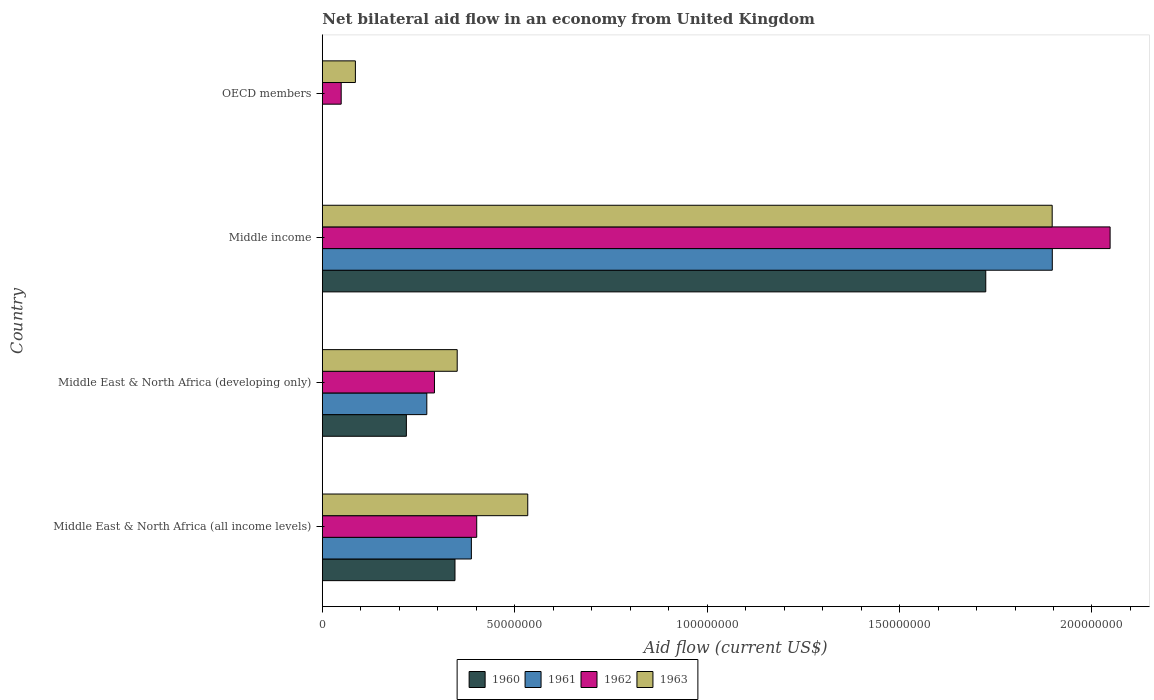How many different coloured bars are there?
Make the answer very short. 4. Are the number of bars per tick equal to the number of legend labels?
Your response must be concise. No. Are the number of bars on each tick of the Y-axis equal?
Your response must be concise. No. How many bars are there on the 4th tick from the top?
Ensure brevity in your answer.  4. How many bars are there on the 1st tick from the bottom?
Keep it short and to the point. 4. Across all countries, what is the maximum net bilateral aid flow in 1961?
Keep it short and to the point. 1.90e+08. What is the total net bilateral aid flow in 1961 in the graph?
Give a very brief answer. 2.56e+08. What is the difference between the net bilateral aid flow in 1963 in Middle East & North Africa (developing only) and that in Middle income?
Offer a terse response. -1.55e+08. What is the difference between the net bilateral aid flow in 1961 in Middle East & North Africa (all income levels) and the net bilateral aid flow in 1960 in Middle income?
Provide a succinct answer. -1.34e+08. What is the average net bilateral aid flow in 1961 per country?
Your answer should be compact. 6.39e+07. What is the difference between the net bilateral aid flow in 1961 and net bilateral aid flow in 1962 in Middle East & North Africa (all income levels)?
Provide a short and direct response. -1.39e+06. What is the ratio of the net bilateral aid flow in 1960 in Middle East & North Africa (developing only) to that in Middle income?
Your answer should be compact. 0.13. Is the difference between the net bilateral aid flow in 1961 in Middle East & North Africa (all income levels) and Middle income greater than the difference between the net bilateral aid flow in 1962 in Middle East & North Africa (all income levels) and Middle income?
Provide a succinct answer. Yes. What is the difference between the highest and the second highest net bilateral aid flow in 1960?
Your answer should be very brief. 1.38e+08. What is the difference between the highest and the lowest net bilateral aid flow in 1962?
Keep it short and to the point. 2.00e+08. Is the sum of the net bilateral aid flow in 1962 in Middle East & North Africa (all income levels) and Middle income greater than the maximum net bilateral aid flow in 1963 across all countries?
Keep it short and to the point. Yes. Is it the case that in every country, the sum of the net bilateral aid flow in 1963 and net bilateral aid flow in 1960 is greater than the net bilateral aid flow in 1961?
Offer a very short reply. Yes. Are all the bars in the graph horizontal?
Keep it short and to the point. Yes. How many countries are there in the graph?
Keep it short and to the point. 4. Does the graph contain any zero values?
Offer a terse response. Yes. How many legend labels are there?
Make the answer very short. 4. What is the title of the graph?
Provide a succinct answer. Net bilateral aid flow in an economy from United Kingdom. What is the label or title of the X-axis?
Make the answer very short. Aid flow (current US$). What is the Aid flow (current US$) of 1960 in Middle East & North Africa (all income levels)?
Your response must be concise. 3.45e+07. What is the Aid flow (current US$) of 1961 in Middle East & North Africa (all income levels)?
Your answer should be very brief. 3.87e+07. What is the Aid flow (current US$) of 1962 in Middle East & North Africa (all income levels)?
Offer a terse response. 4.01e+07. What is the Aid flow (current US$) in 1963 in Middle East & North Africa (all income levels)?
Give a very brief answer. 5.34e+07. What is the Aid flow (current US$) of 1960 in Middle East & North Africa (developing only)?
Your response must be concise. 2.18e+07. What is the Aid flow (current US$) of 1961 in Middle East & North Africa (developing only)?
Offer a very short reply. 2.72e+07. What is the Aid flow (current US$) in 1962 in Middle East & North Africa (developing only)?
Your answer should be compact. 2.91e+07. What is the Aid flow (current US$) in 1963 in Middle East & North Africa (developing only)?
Keep it short and to the point. 3.50e+07. What is the Aid flow (current US$) in 1960 in Middle income?
Make the answer very short. 1.72e+08. What is the Aid flow (current US$) of 1961 in Middle income?
Offer a very short reply. 1.90e+08. What is the Aid flow (current US$) in 1962 in Middle income?
Offer a very short reply. 2.05e+08. What is the Aid flow (current US$) of 1963 in Middle income?
Make the answer very short. 1.90e+08. What is the Aid flow (current US$) in 1962 in OECD members?
Your response must be concise. 4.90e+06. What is the Aid flow (current US$) in 1963 in OECD members?
Offer a terse response. 8.59e+06. Across all countries, what is the maximum Aid flow (current US$) of 1960?
Provide a succinct answer. 1.72e+08. Across all countries, what is the maximum Aid flow (current US$) of 1961?
Provide a short and direct response. 1.90e+08. Across all countries, what is the maximum Aid flow (current US$) in 1962?
Provide a short and direct response. 2.05e+08. Across all countries, what is the maximum Aid flow (current US$) of 1963?
Your answer should be compact. 1.90e+08. Across all countries, what is the minimum Aid flow (current US$) of 1960?
Give a very brief answer. 0. Across all countries, what is the minimum Aid flow (current US$) of 1962?
Keep it short and to the point. 4.90e+06. Across all countries, what is the minimum Aid flow (current US$) of 1963?
Give a very brief answer. 8.59e+06. What is the total Aid flow (current US$) of 1960 in the graph?
Ensure brevity in your answer.  2.29e+08. What is the total Aid flow (current US$) in 1961 in the graph?
Provide a succinct answer. 2.56e+08. What is the total Aid flow (current US$) of 1962 in the graph?
Offer a terse response. 2.79e+08. What is the total Aid flow (current US$) of 1963 in the graph?
Provide a short and direct response. 2.87e+08. What is the difference between the Aid flow (current US$) of 1960 in Middle East & North Africa (all income levels) and that in Middle East & North Africa (developing only)?
Offer a terse response. 1.26e+07. What is the difference between the Aid flow (current US$) in 1961 in Middle East & North Africa (all income levels) and that in Middle East & North Africa (developing only)?
Offer a terse response. 1.16e+07. What is the difference between the Aid flow (current US$) in 1962 in Middle East & North Africa (all income levels) and that in Middle East & North Africa (developing only)?
Your answer should be very brief. 1.10e+07. What is the difference between the Aid flow (current US$) in 1963 in Middle East & North Africa (all income levels) and that in Middle East & North Africa (developing only)?
Ensure brevity in your answer.  1.83e+07. What is the difference between the Aid flow (current US$) in 1960 in Middle East & North Africa (all income levels) and that in Middle income?
Make the answer very short. -1.38e+08. What is the difference between the Aid flow (current US$) in 1961 in Middle East & North Africa (all income levels) and that in Middle income?
Your response must be concise. -1.51e+08. What is the difference between the Aid flow (current US$) of 1962 in Middle East & North Africa (all income levels) and that in Middle income?
Keep it short and to the point. -1.65e+08. What is the difference between the Aid flow (current US$) of 1963 in Middle East & North Africa (all income levels) and that in Middle income?
Keep it short and to the point. -1.36e+08. What is the difference between the Aid flow (current US$) of 1962 in Middle East & North Africa (all income levels) and that in OECD members?
Give a very brief answer. 3.52e+07. What is the difference between the Aid flow (current US$) of 1963 in Middle East & North Africa (all income levels) and that in OECD members?
Ensure brevity in your answer.  4.48e+07. What is the difference between the Aid flow (current US$) in 1960 in Middle East & North Africa (developing only) and that in Middle income?
Your answer should be very brief. -1.51e+08. What is the difference between the Aid flow (current US$) in 1961 in Middle East & North Africa (developing only) and that in Middle income?
Your answer should be compact. -1.63e+08. What is the difference between the Aid flow (current US$) of 1962 in Middle East & North Africa (developing only) and that in Middle income?
Offer a very short reply. -1.76e+08. What is the difference between the Aid flow (current US$) of 1963 in Middle East & North Africa (developing only) and that in Middle income?
Keep it short and to the point. -1.55e+08. What is the difference between the Aid flow (current US$) of 1962 in Middle East & North Africa (developing only) and that in OECD members?
Give a very brief answer. 2.42e+07. What is the difference between the Aid flow (current US$) of 1963 in Middle East & North Africa (developing only) and that in OECD members?
Offer a terse response. 2.65e+07. What is the difference between the Aid flow (current US$) of 1962 in Middle income and that in OECD members?
Your response must be concise. 2.00e+08. What is the difference between the Aid flow (current US$) of 1963 in Middle income and that in OECD members?
Give a very brief answer. 1.81e+08. What is the difference between the Aid flow (current US$) in 1960 in Middle East & North Africa (all income levels) and the Aid flow (current US$) in 1961 in Middle East & North Africa (developing only)?
Provide a succinct answer. 7.32e+06. What is the difference between the Aid flow (current US$) of 1960 in Middle East & North Africa (all income levels) and the Aid flow (current US$) of 1962 in Middle East & North Africa (developing only)?
Your response must be concise. 5.33e+06. What is the difference between the Aid flow (current US$) in 1960 in Middle East & North Africa (all income levels) and the Aid flow (current US$) in 1963 in Middle East & North Africa (developing only)?
Keep it short and to the point. -5.80e+05. What is the difference between the Aid flow (current US$) of 1961 in Middle East & North Africa (all income levels) and the Aid flow (current US$) of 1962 in Middle East & North Africa (developing only)?
Your response must be concise. 9.59e+06. What is the difference between the Aid flow (current US$) of 1961 in Middle East & North Africa (all income levels) and the Aid flow (current US$) of 1963 in Middle East & North Africa (developing only)?
Your answer should be compact. 3.68e+06. What is the difference between the Aid flow (current US$) in 1962 in Middle East & North Africa (all income levels) and the Aid flow (current US$) in 1963 in Middle East & North Africa (developing only)?
Your answer should be very brief. 5.07e+06. What is the difference between the Aid flow (current US$) of 1960 in Middle East & North Africa (all income levels) and the Aid flow (current US$) of 1961 in Middle income?
Make the answer very short. -1.55e+08. What is the difference between the Aid flow (current US$) in 1960 in Middle East & North Africa (all income levels) and the Aid flow (current US$) in 1962 in Middle income?
Provide a short and direct response. -1.70e+08. What is the difference between the Aid flow (current US$) in 1960 in Middle East & North Africa (all income levels) and the Aid flow (current US$) in 1963 in Middle income?
Keep it short and to the point. -1.55e+08. What is the difference between the Aid flow (current US$) of 1961 in Middle East & North Africa (all income levels) and the Aid flow (current US$) of 1962 in Middle income?
Provide a short and direct response. -1.66e+08. What is the difference between the Aid flow (current US$) in 1961 in Middle East & North Africa (all income levels) and the Aid flow (current US$) in 1963 in Middle income?
Keep it short and to the point. -1.51e+08. What is the difference between the Aid flow (current US$) in 1962 in Middle East & North Africa (all income levels) and the Aid flow (current US$) in 1963 in Middle income?
Make the answer very short. -1.50e+08. What is the difference between the Aid flow (current US$) in 1960 in Middle East & North Africa (all income levels) and the Aid flow (current US$) in 1962 in OECD members?
Give a very brief answer. 2.96e+07. What is the difference between the Aid flow (current US$) in 1960 in Middle East & North Africa (all income levels) and the Aid flow (current US$) in 1963 in OECD members?
Ensure brevity in your answer.  2.59e+07. What is the difference between the Aid flow (current US$) of 1961 in Middle East & North Africa (all income levels) and the Aid flow (current US$) of 1962 in OECD members?
Make the answer very short. 3.38e+07. What is the difference between the Aid flow (current US$) in 1961 in Middle East & North Africa (all income levels) and the Aid flow (current US$) in 1963 in OECD members?
Provide a succinct answer. 3.01e+07. What is the difference between the Aid flow (current US$) of 1962 in Middle East & North Africa (all income levels) and the Aid flow (current US$) of 1963 in OECD members?
Offer a terse response. 3.15e+07. What is the difference between the Aid flow (current US$) in 1960 in Middle East & North Africa (developing only) and the Aid flow (current US$) in 1961 in Middle income?
Provide a succinct answer. -1.68e+08. What is the difference between the Aid flow (current US$) in 1960 in Middle East & North Africa (developing only) and the Aid flow (current US$) in 1962 in Middle income?
Your answer should be very brief. -1.83e+08. What is the difference between the Aid flow (current US$) of 1960 in Middle East & North Africa (developing only) and the Aid flow (current US$) of 1963 in Middle income?
Make the answer very short. -1.68e+08. What is the difference between the Aid flow (current US$) of 1961 in Middle East & North Africa (developing only) and the Aid flow (current US$) of 1962 in Middle income?
Provide a short and direct response. -1.78e+08. What is the difference between the Aid flow (current US$) of 1961 in Middle East & North Africa (developing only) and the Aid flow (current US$) of 1963 in Middle income?
Ensure brevity in your answer.  -1.63e+08. What is the difference between the Aid flow (current US$) of 1962 in Middle East & North Africa (developing only) and the Aid flow (current US$) of 1963 in Middle income?
Your answer should be compact. -1.61e+08. What is the difference between the Aid flow (current US$) in 1960 in Middle East & North Africa (developing only) and the Aid flow (current US$) in 1962 in OECD members?
Give a very brief answer. 1.69e+07. What is the difference between the Aid flow (current US$) of 1960 in Middle East & North Africa (developing only) and the Aid flow (current US$) of 1963 in OECD members?
Provide a succinct answer. 1.32e+07. What is the difference between the Aid flow (current US$) of 1961 in Middle East & North Africa (developing only) and the Aid flow (current US$) of 1962 in OECD members?
Your answer should be very brief. 2.22e+07. What is the difference between the Aid flow (current US$) of 1961 in Middle East & North Africa (developing only) and the Aid flow (current US$) of 1963 in OECD members?
Offer a terse response. 1.86e+07. What is the difference between the Aid flow (current US$) of 1962 in Middle East & North Africa (developing only) and the Aid flow (current US$) of 1963 in OECD members?
Make the answer very short. 2.06e+07. What is the difference between the Aid flow (current US$) in 1960 in Middle income and the Aid flow (current US$) in 1962 in OECD members?
Your answer should be very brief. 1.68e+08. What is the difference between the Aid flow (current US$) in 1960 in Middle income and the Aid flow (current US$) in 1963 in OECD members?
Provide a succinct answer. 1.64e+08. What is the difference between the Aid flow (current US$) in 1961 in Middle income and the Aid flow (current US$) in 1962 in OECD members?
Keep it short and to the point. 1.85e+08. What is the difference between the Aid flow (current US$) of 1961 in Middle income and the Aid flow (current US$) of 1963 in OECD members?
Offer a very short reply. 1.81e+08. What is the difference between the Aid flow (current US$) of 1962 in Middle income and the Aid flow (current US$) of 1963 in OECD members?
Ensure brevity in your answer.  1.96e+08. What is the average Aid flow (current US$) in 1960 per country?
Give a very brief answer. 5.72e+07. What is the average Aid flow (current US$) in 1961 per country?
Your answer should be compact. 6.39e+07. What is the average Aid flow (current US$) in 1962 per country?
Offer a terse response. 6.97e+07. What is the average Aid flow (current US$) in 1963 per country?
Your answer should be very brief. 7.17e+07. What is the difference between the Aid flow (current US$) of 1960 and Aid flow (current US$) of 1961 in Middle East & North Africa (all income levels)?
Offer a very short reply. -4.26e+06. What is the difference between the Aid flow (current US$) in 1960 and Aid flow (current US$) in 1962 in Middle East & North Africa (all income levels)?
Make the answer very short. -5.65e+06. What is the difference between the Aid flow (current US$) in 1960 and Aid flow (current US$) in 1963 in Middle East & North Africa (all income levels)?
Make the answer very short. -1.89e+07. What is the difference between the Aid flow (current US$) of 1961 and Aid flow (current US$) of 1962 in Middle East & North Africa (all income levels)?
Make the answer very short. -1.39e+06. What is the difference between the Aid flow (current US$) of 1961 and Aid flow (current US$) of 1963 in Middle East & North Africa (all income levels)?
Ensure brevity in your answer.  -1.46e+07. What is the difference between the Aid flow (current US$) of 1962 and Aid flow (current US$) of 1963 in Middle East & North Africa (all income levels)?
Your answer should be compact. -1.33e+07. What is the difference between the Aid flow (current US$) in 1960 and Aid flow (current US$) in 1961 in Middle East & North Africa (developing only)?
Ensure brevity in your answer.  -5.31e+06. What is the difference between the Aid flow (current US$) of 1960 and Aid flow (current US$) of 1962 in Middle East & North Africa (developing only)?
Keep it short and to the point. -7.30e+06. What is the difference between the Aid flow (current US$) of 1960 and Aid flow (current US$) of 1963 in Middle East & North Africa (developing only)?
Make the answer very short. -1.32e+07. What is the difference between the Aid flow (current US$) of 1961 and Aid flow (current US$) of 1962 in Middle East & North Africa (developing only)?
Give a very brief answer. -1.99e+06. What is the difference between the Aid flow (current US$) of 1961 and Aid flow (current US$) of 1963 in Middle East & North Africa (developing only)?
Keep it short and to the point. -7.90e+06. What is the difference between the Aid flow (current US$) of 1962 and Aid flow (current US$) of 1963 in Middle East & North Africa (developing only)?
Your answer should be compact. -5.91e+06. What is the difference between the Aid flow (current US$) of 1960 and Aid flow (current US$) of 1961 in Middle income?
Your answer should be very brief. -1.73e+07. What is the difference between the Aid flow (current US$) of 1960 and Aid flow (current US$) of 1962 in Middle income?
Provide a short and direct response. -3.23e+07. What is the difference between the Aid flow (current US$) of 1960 and Aid flow (current US$) of 1963 in Middle income?
Give a very brief answer. -1.73e+07. What is the difference between the Aid flow (current US$) in 1961 and Aid flow (current US$) in 1962 in Middle income?
Keep it short and to the point. -1.50e+07. What is the difference between the Aid flow (current US$) of 1962 and Aid flow (current US$) of 1963 in Middle income?
Offer a very short reply. 1.50e+07. What is the difference between the Aid flow (current US$) in 1962 and Aid flow (current US$) in 1963 in OECD members?
Your response must be concise. -3.69e+06. What is the ratio of the Aid flow (current US$) in 1960 in Middle East & North Africa (all income levels) to that in Middle East & North Africa (developing only)?
Give a very brief answer. 1.58. What is the ratio of the Aid flow (current US$) of 1961 in Middle East & North Africa (all income levels) to that in Middle East & North Africa (developing only)?
Ensure brevity in your answer.  1.43. What is the ratio of the Aid flow (current US$) of 1962 in Middle East & North Africa (all income levels) to that in Middle East & North Africa (developing only)?
Ensure brevity in your answer.  1.38. What is the ratio of the Aid flow (current US$) in 1963 in Middle East & North Africa (all income levels) to that in Middle East & North Africa (developing only)?
Offer a very short reply. 1.52. What is the ratio of the Aid flow (current US$) of 1960 in Middle East & North Africa (all income levels) to that in Middle income?
Provide a short and direct response. 0.2. What is the ratio of the Aid flow (current US$) of 1961 in Middle East & North Africa (all income levels) to that in Middle income?
Make the answer very short. 0.2. What is the ratio of the Aid flow (current US$) in 1962 in Middle East & North Africa (all income levels) to that in Middle income?
Provide a short and direct response. 0.2. What is the ratio of the Aid flow (current US$) in 1963 in Middle East & North Africa (all income levels) to that in Middle income?
Keep it short and to the point. 0.28. What is the ratio of the Aid flow (current US$) in 1962 in Middle East & North Africa (all income levels) to that in OECD members?
Your answer should be compact. 8.19. What is the ratio of the Aid flow (current US$) of 1963 in Middle East & North Africa (all income levels) to that in OECD members?
Give a very brief answer. 6.21. What is the ratio of the Aid flow (current US$) in 1960 in Middle East & North Africa (developing only) to that in Middle income?
Give a very brief answer. 0.13. What is the ratio of the Aid flow (current US$) of 1961 in Middle East & North Africa (developing only) to that in Middle income?
Ensure brevity in your answer.  0.14. What is the ratio of the Aid flow (current US$) of 1962 in Middle East & North Africa (developing only) to that in Middle income?
Your answer should be compact. 0.14. What is the ratio of the Aid flow (current US$) of 1963 in Middle East & North Africa (developing only) to that in Middle income?
Offer a terse response. 0.18. What is the ratio of the Aid flow (current US$) of 1962 in Middle East & North Africa (developing only) to that in OECD members?
Keep it short and to the point. 5.95. What is the ratio of the Aid flow (current US$) in 1963 in Middle East & North Africa (developing only) to that in OECD members?
Give a very brief answer. 4.08. What is the ratio of the Aid flow (current US$) of 1962 in Middle income to that in OECD members?
Ensure brevity in your answer.  41.78. What is the ratio of the Aid flow (current US$) of 1963 in Middle income to that in OECD members?
Offer a very short reply. 22.08. What is the difference between the highest and the second highest Aid flow (current US$) in 1960?
Your response must be concise. 1.38e+08. What is the difference between the highest and the second highest Aid flow (current US$) in 1961?
Offer a terse response. 1.51e+08. What is the difference between the highest and the second highest Aid flow (current US$) of 1962?
Make the answer very short. 1.65e+08. What is the difference between the highest and the second highest Aid flow (current US$) in 1963?
Your answer should be compact. 1.36e+08. What is the difference between the highest and the lowest Aid flow (current US$) of 1960?
Your response must be concise. 1.72e+08. What is the difference between the highest and the lowest Aid flow (current US$) of 1961?
Keep it short and to the point. 1.90e+08. What is the difference between the highest and the lowest Aid flow (current US$) in 1962?
Offer a very short reply. 2.00e+08. What is the difference between the highest and the lowest Aid flow (current US$) of 1963?
Keep it short and to the point. 1.81e+08. 